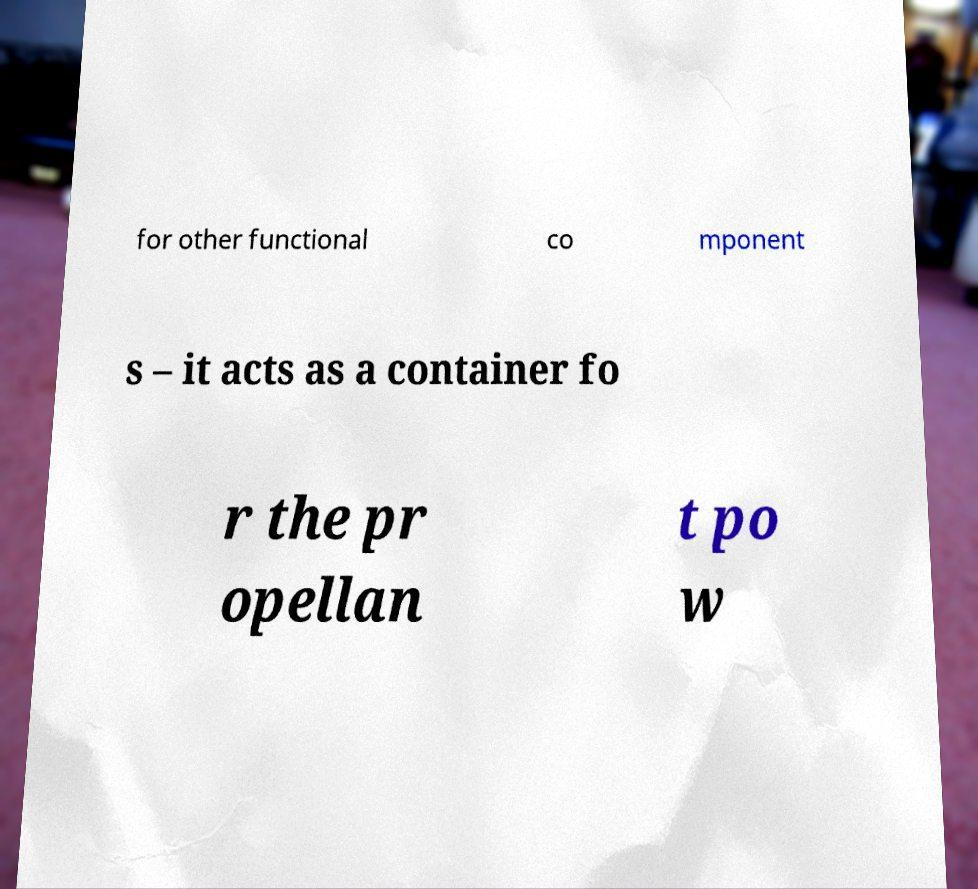Please read and relay the text visible in this image. What does it say? for other functional co mponent s – it acts as a container fo r the pr opellan t po w 